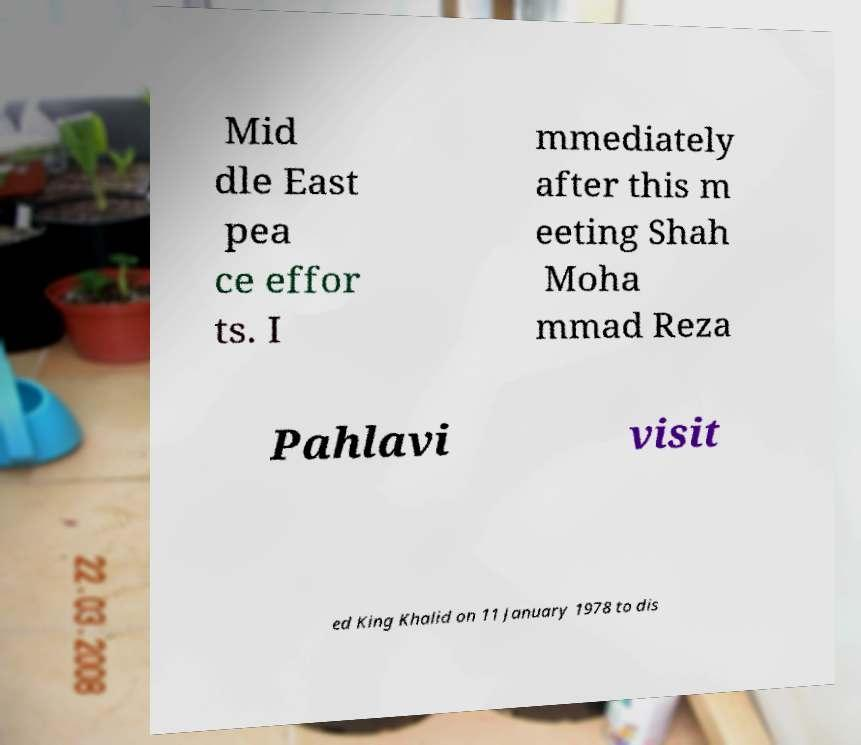Could you assist in decoding the text presented in this image and type it out clearly? Mid dle East pea ce effor ts. I mmediately after this m eeting Shah Moha mmad Reza Pahlavi visit ed King Khalid on 11 January 1978 to dis 